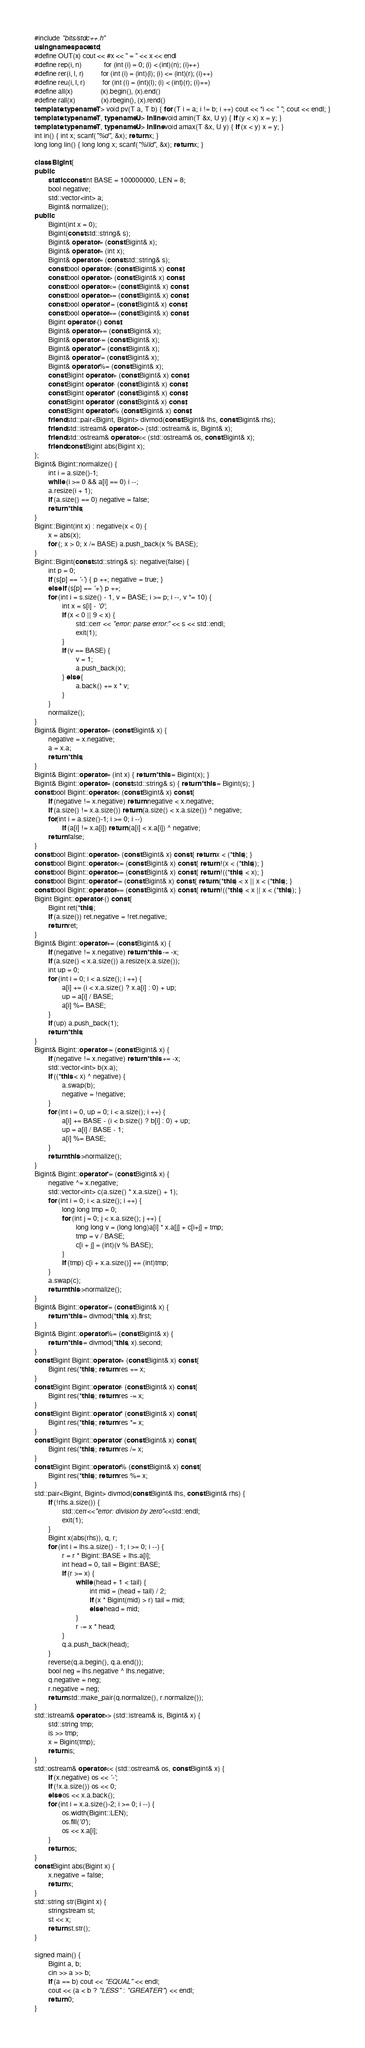<code> <loc_0><loc_0><loc_500><loc_500><_C++_>#include "bits/stdc++.h"
using namespace std;
#define OUT(x) cout << #x << " = " << x << endl
#define rep(i, n)             for (int (i) = 0; (i) < (int)(n); (i)++)
#define rer(i, l, r)          for (int (i) = (int)(l); (i) <= (int)(r); (i)++)
#define reu(i, l, r)          for (int (i) = (int)(l); (i) < (int)(r); (i)++)
#define all(x)                (x).begin(), (x).end()
#define rall(x)               (x).rbegin(), (x).rend()
template<typename T> void pv(T a, T b) { for (T i = a; i != b; i ++) cout << *i << " "; cout << endl; }
template<typename T, typename U> inline void amin(T &x, U y) { if (y < x) x = y; }
template<typename T, typename U> inline void amax(T &x, U y) { if (x < y) x = y; }
int in() { int x; scanf("%d", &x); return x; }
long long lin() { long long x; scanf("%lld", &x); return x; }

class Bigint {
public:
        static const int BASE = 100000000, LEN = 8;
        bool negative;
        std::vector<int> a;
        Bigint& normalize();
public:
        Bigint(int x = 0);
        Bigint(const std::string& s);
        Bigint& operator = (const Bigint& x);
        Bigint& operator = (int x);
        Bigint& operator = (const std::string& s);
        const bool operator < (const Bigint& x) const;
        const bool operator > (const Bigint& x) const;
        const bool operator <= (const Bigint& x) const;
        const bool operator >= (const Bigint& x) const;
        const bool operator != (const Bigint& x) const;
        const bool operator == (const Bigint& x) const;
        Bigint operator -() const;
        Bigint& operator += (const Bigint& x);
        Bigint& operator -= (const Bigint& x);
        Bigint& operator *= (const Bigint& x);
        Bigint& operator /= (const Bigint& x);
        Bigint& operator %= (const Bigint& x);
        const Bigint operator + (const Bigint& x) const;
        const Bigint operator - (const Bigint& x) const;
        const Bigint operator * (const Bigint& x) const;
        const Bigint operator / (const Bigint& x) const;
        const Bigint operator % (const Bigint& x) const;
        friend std::pair<Bigint, Bigint> divmod(const Bigint& lhs, const Bigint& rhs);
        friend std::istream& operator >> (std::ostream& is, Bigint& x);
        friend std::ostream& operator << (std::ostream& os, const Bigint& x);
        friend const Bigint abs(Bigint x);
};
Bigint& Bigint::normalize() {
        int i = a.size()-1;
        while (i >= 0 && a[i] == 0) i --;
        a.resize(i + 1);
        if (a.size() == 0) negative = false;
        return *this;
}
Bigint::Bigint(int x) : negative(x < 0) {
        x = abs(x);
        for (; x > 0; x /= BASE) a.push_back(x % BASE);
}
Bigint::Bigint(const std::string& s): negative(false) {
        int p = 0;
        if (s[p] == '-') { p ++; negative = true; }
        else if (s[p] == '+') p ++;
        for (int i = s.size() - 1, v = BASE; i >= p; i --, v *= 10) {
                int x = s[i] - '0';
                if (x < 0 || 9 < x) {
                        std::cerr << "error: parse error:" << s << std::endl;
                        exit(1);
                } 
                if (v == BASE) {
                        v = 1;
                        a.push_back(x);
                } else {
                        a.back() += x * v;
                }
        }
        normalize();
}
Bigint& Bigint::operator = (const Bigint& x) {
        negative = x.negative;
        a = x.a;
        return *this;
}
Bigint& Bigint::operator = (int x) { return *this = Bigint(x); }
Bigint& Bigint::operator = (const std::string& s) { return *this = Bigint(s); }
const bool Bigint::operator < (const Bigint& x) const {
        if (negative != x.negative) return negative < x.negative;
        if (a.size() != x.a.size()) return (a.size() < x.a.size()) ^ negative;
        for(int i = a.size()-1; i >= 0; i --)
                if (a[i] != x.a[i]) return (a[i] < x.a[i]) ^ negative;
        return false;
}
const bool Bigint::operator > (const Bigint& x) const { return x < (*this); }
const bool Bigint::operator <= (const Bigint& x) const { return !(x < (*this)); }
const bool Bigint::operator >= (const Bigint& x) const { return !((*this) < x); }
const bool Bigint::operator != (const Bigint& x) const { return (*this) < x || x < (*this); }
const bool Bigint::operator == (const Bigint& x) const { return !((*this) < x || x < (*this)); }
Bigint Bigint::operator -() const {
        Bigint ret(*this);
        if (a.size()) ret.negative = !ret.negative;
        return ret;
}
Bigint& Bigint::operator += (const Bigint& x) {
        if (negative != x.negative) return *this -= -x;
        if (a.size() < x.a.size()) a.resize(x.a.size());
        int up = 0;
        for (int i = 0; i < a.size(); i ++) {
                a[i] += (i < x.a.size() ? x.a[i] : 0) + up;
                up = a[i] / BASE;
                a[i] %= BASE;
        }
        if (up) a.push_back(1);
        return *this;
}
Bigint& Bigint::operator -= (const Bigint& x) {
        if (negative != x.negative) return *this += -x;
        std::vector<int> b(x.a);
        if ((*this < x) ^ negative) {
                a.swap(b);
                negative = !negative;
        }
        for (int i = 0, up = 0; i < a.size(); i ++) {
                a[i] += BASE - (i < b.size() ? b[i] : 0) + up;
                up = a[i] / BASE - 1;
                a[i] %= BASE;
        }
        return this->normalize();
}
Bigint& Bigint::operator *= (const Bigint& x) {
        negative ^= x.negative;
        std::vector<int> c(a.size() * x.a.size() + 1);
        for (int i = 0; i < a.size(); i ++) {
                long long tmp = 0;
                for (int j = 0; j < x.a.size(); j ++) {
                        long long v = (long long)a[i] * x.a[j] + c[i+j] + tmp;
                        tmp = v / BASE;
                        c[i + j] = (int)(v % BASE);
                }
                if (tmp) c[i + x.a.size()] += (int)tmp;
        }
        a.swap(c);
        return this->normalize();
}
Bigint& Bigint::operator /= (const Bigint& x) {
        return *this = divmod(*this, x).first;
}
Bigint& Bigint::operator %= (const Bigint& x) {
        return *this = divmod(*this, x).second;
}
const Bigint Bigint::operator + (const Bigint& x) const {
        Bigint res(*this); return res += x;
}
const Bigint Bigint::operator - (const Bigint& x) const {
        Bigint res(*this); return res -= x;
}
const Bigint Bigint::operator * (const Bigint& x) const {
        Bigint res(*this); return res *= x;
}
const Bigint Bigint::operator / (const Bigint& x) const {
        Bigint res(*this); return res /= x;
}
const Bigint Bigint::operator % (const Bigint& x) const {
        Bigint res(*this); return res %= x;
}
std::pair<Bigint, Bigint> divmod(const Bigint& lhs, const Bigint& rhs) {
        if (!rhs.a.size()) {
                std::cerr<<"error: division by zero"<<std::endl;
                exit(1);
        }
        Bigint x(abs(rhs)), q, r;
        for (int i = lhs.a.size() - 1; i >= 0; i --) {
                r = r * Bigint::BASE + lhs.a[i];
                int head = 0, tail = Bigint::BASE;
                if (r >= x) {
                        while (head + 1 < tail) {
                                int mid = (head + tail) / 2;
                                if (x * Bigint(mid) > r) tail = mid;
                                else head = mid;
                        }
                        r -= x * head;
                }
                q.a.push_back(head);
        }
        reverse(q.a.begin(), q.a.end());
        bool neg = lhs.negative ^ lhs.negative;
        q.negative = neg;
        r.negative = neg;
        return std::make_pair(q.normalize(), r.normalize());
}
std::istream& operator >> (std::istream& is, Bigint& x) {
        std::string tmp;
        is >> tmp;
        x = Bigint(tmp);
        return is;
}
std::ostream& operator << (std::ostream& os, const Bigint& x) {
        if (x.negative) os << '-';
        if (!x.a.size()) os << 0;
        else os << x.a.back();
        for (int i = x.a.size()-2; i >= 0; i --) {
                os.width(Bigint::LEN);
                os.fill('0');
                os << x.a[i];
        }
        return os;
}
const Bigint abs(Bigint x) {
        x.negative = false;
        return x;
}
std::string str(Bigint x) {
        stringstream st;
        st << x;
        return st.str();
}

signed main() { 
        Bigint a, b;
        cin >> a >> b;
        if (a == b) cout << "EQUAL" << endl;
        cout << (a < b ? "LESS" : "GREATER") << endl;
        return 0;
}               

</code> 